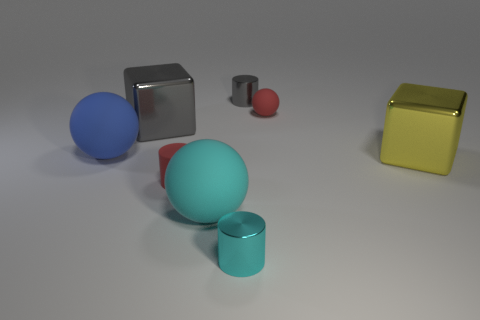Can you describe the different colors and shapes of the objects in the image? Certainly! There's a blue sphere, a red sphere, and a smaller maroon cylinder. A cyan cylinder lies beside a teal spherical object, and there are also two cubes: one is grey and the other has a reflective gold surface. 